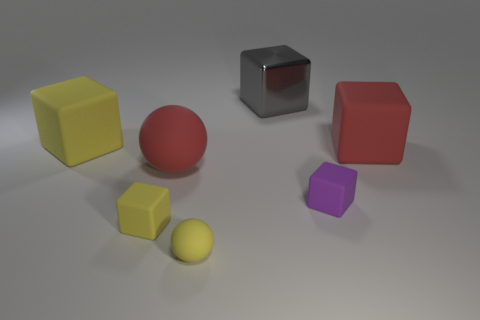Subtract all small yellow matte blocks. How many blocks are left? 4 Add 1 big red metallic blocks. How many objects exist? 8 Subtract all gray cubes. How many cubes are left? 4 Subtract all spheres. How many objects are left? 5 Subtract all brown balls. Subtract all blue cylinders. How many balls are left? 2 Subtract all blue cubes. How many yellow balls are left? 1 Subtract all small red rubber spheres. Subtract all gray shiny things. How many objects are left? 6 Add 4 red blocks. How many red blocks are left? 5 Add 3 yellow matte cubes. How many yellow matte cubes exist? 5 Subtract 0 yellow cylinders. How many objects are left? 7 